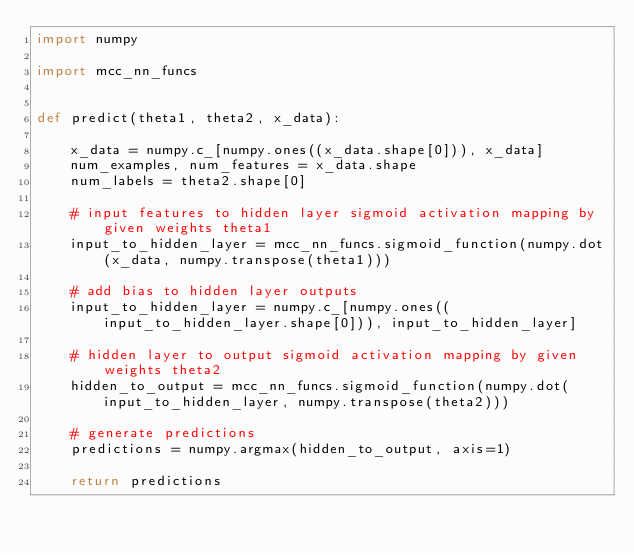<code> <loc_0><loc_0><loc_500><loc_500><_Python_>import numpy

import mcc_nn_funcs


def predict(theta1, theta2, x_data):

    x_data = numpy.c_[numpy.ones((x_data.shape[0])), x_data]
    num_examples, num_features = x_data.shape
    num_labels = theta2.shape[0]

    # input features to hidden layer sigmoid activation mapping by given weights theta1
    input_to_hidden_layer = mcc_nn_funcs.sigmoid_function(numpy.dot(x_data, numpy.transpose(theta1)))

    # add bias to hidden layer outputs
    input_to_hidden_layer = numpy.c_[numpy.ones((input_to_hidden_layer.shape[0])), input_to_hidden_layer]

    # hidden layer to output sigmoid activation mapping by given weights theta2
    hidden_to_output = mcc_nn_funcs.sigmoid_function(numpy.dot(input_to_hidden_layer, numpy.transpose(theta2)))

    # generate predictions
    predictions = numpy.argmax(hidden_to_output, axis=1)

    return predictions
</code> 